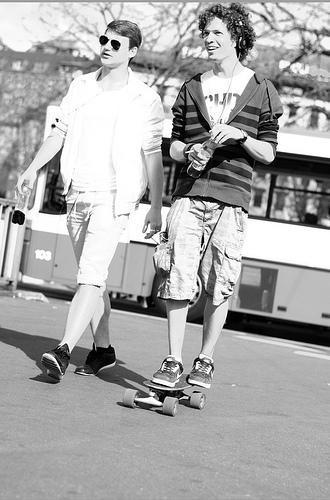How many people are in the image?
Give a very brief answer. 2. 